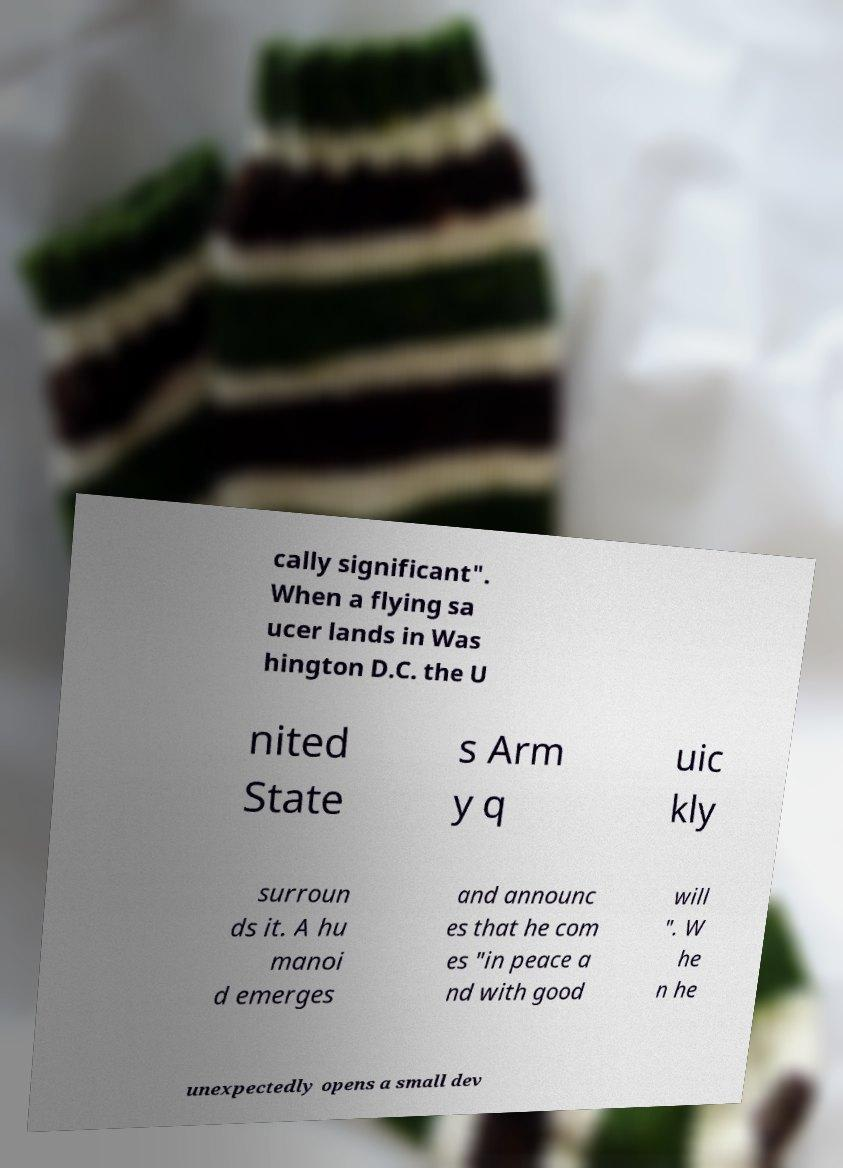Please read and relay the text visible in this image. What does it say? cally significant". When a flying sa ucer lands in Was hington D.C. the U nited State s Arm y q uic kly surroun ds it. A hu manoi d emerges and announc es that he com es "in peace a nd with good will ". W he n he unexpectedly opens a small dev 